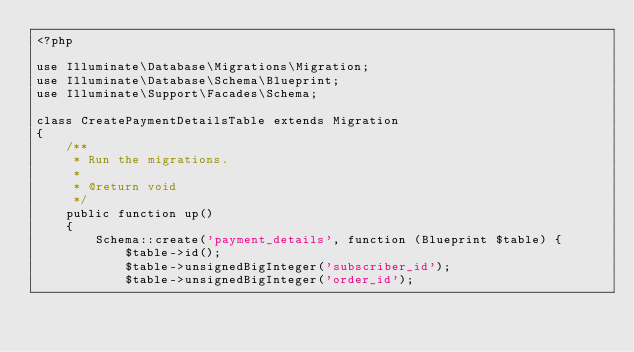Convert code to text. <code><loc_0><loc_0><loc_500><loc_500><_PHP_><?php

use Illuminate\Database\Migrations\Migration;
use Illuminate\Database\Schema\Blueprint;
use Illuminate\Support\Facades\Schema;

class CreatePaymentDetailsTable extends Migration
{
    /**
     * Run the migrations.
     *
     * @return void
     */
    public function up()
    {
        Schema::create('payment_details', function (Blueprint $table) {
            $table->id();
            $table->unsignedBigInteger('subscriber_id');
            $table->unsignedBigInteger('order_id');</code> 